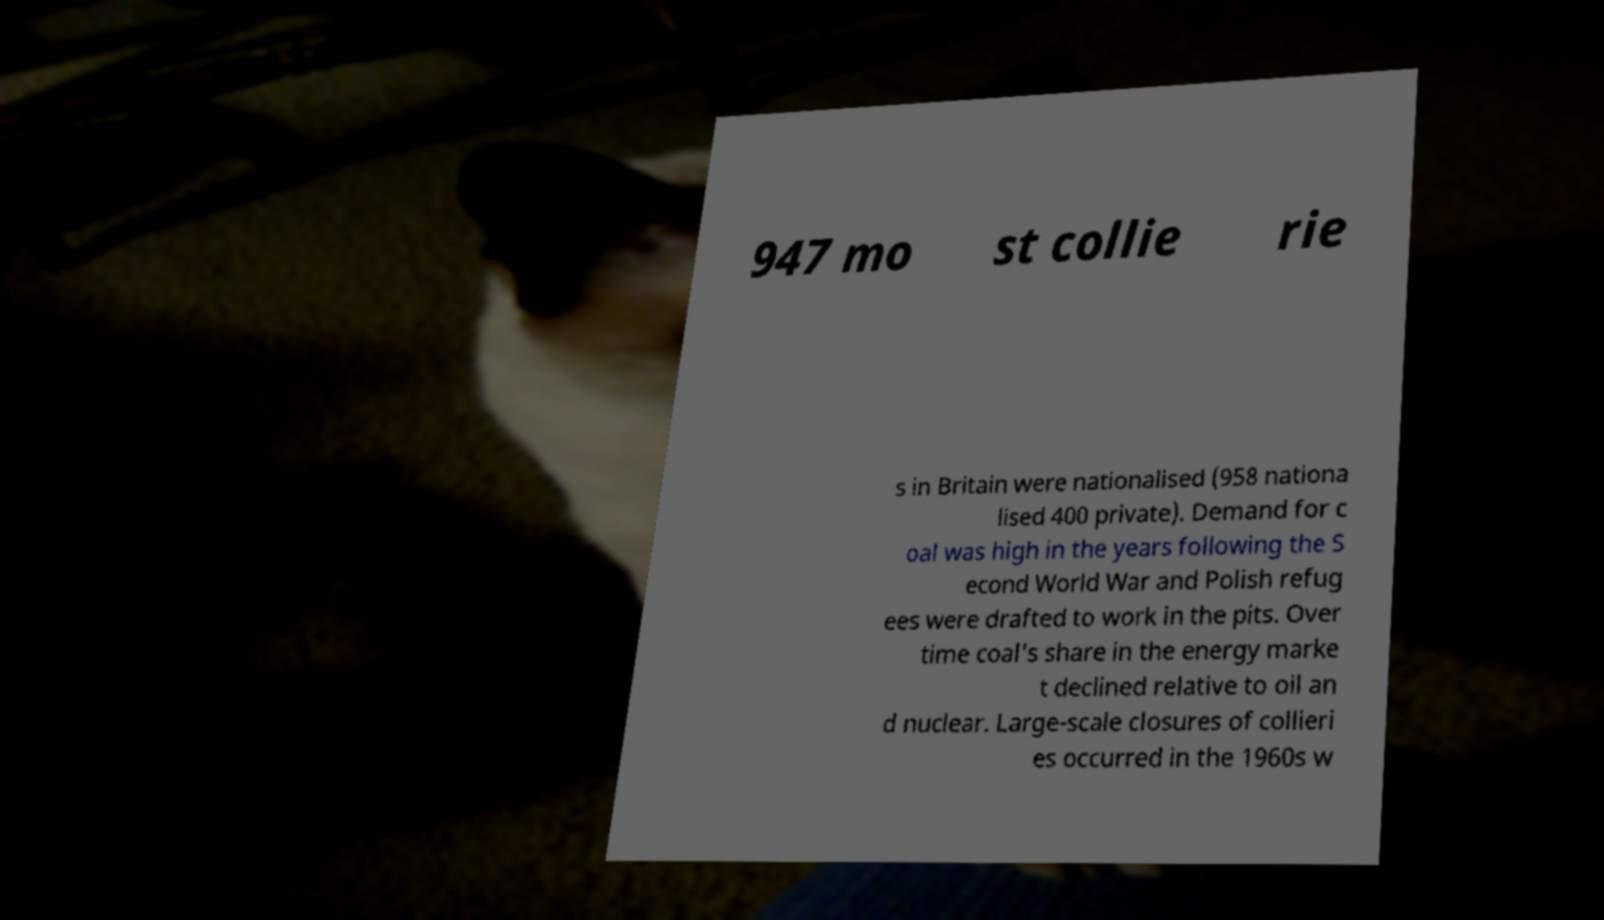What messages or text are displayed in this image? I need them in a readable, typed format. 947 mo st collie rie s in Britain were nationalised (958 nationa lised 400 private). Demand for c oal was high in the years following the S econd World War and Polish refug ees were drafted to work in the pits. Over time coal's share in the energy marke t declined relative to oil an d nuclear. Large-scale closures of collieri es occurred in the 1960s w 